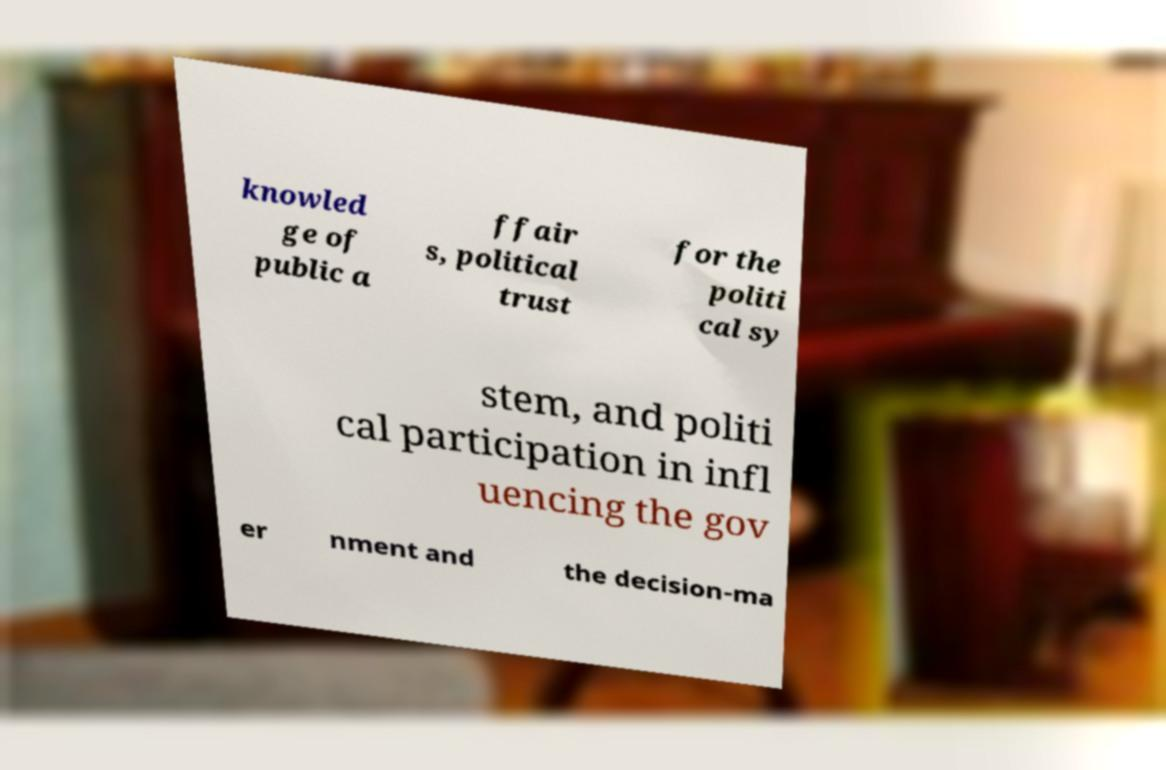I need the written content from this picture converted into text. Can you do that? knowled ge of public a ffair s, political trust for the politi cal sy stem, and politi cal participation in infl uencing the gov er nment and the decision-ma 